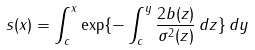<formula> <loc_0><loc_0><loc_500><loc_500>s ( x ) = \int _ { c } ^ { x } \exp \{ - \int _ { c } ^ { y } \frac { 2 b ( z ) } { \sigma ^ { 2 } ( z ) } \, d z \} \, d y</formula> 